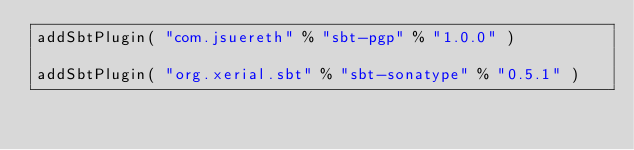Convert code to text. <code><loc_0><loc_0><loc_500><loc_500><_Scala_>addSbtPlugin( "com.jsuereth" % "sbt-pgp" % "1.0.0" )

addSbtPlugin( "org.xerial.sbt" % "sbt-sonatype" % "0.5.1" )</code> 